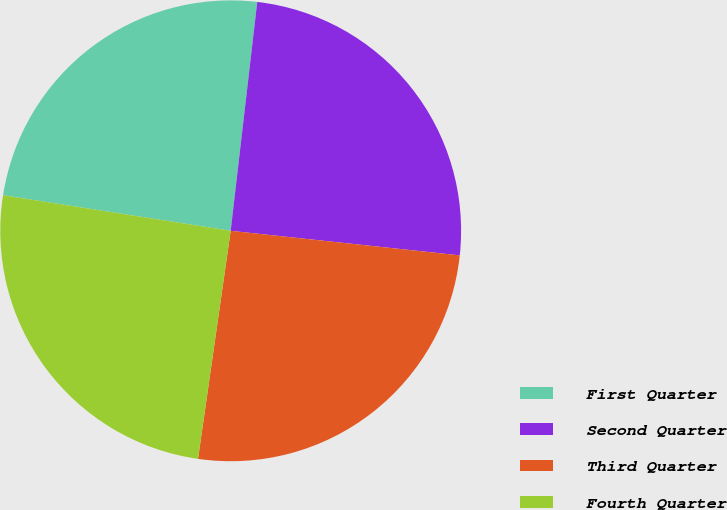Convert chart. <chart><loc_0><loc_0><loc_500><loc_500><pie_chart><fcel>First Quarter<fcel>Second Quarter<fcel>Third Quarter<fcel>Fourth Quarter<nl><fcel>24.37%<fcel>24.86%<fcel>25.56%<fcel>25.2%<nl></chart> 